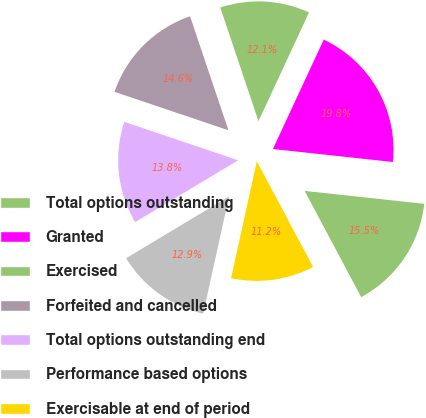Convert chart to OTSL. <chart><loc_0><loc_0><loc_500><loc_500><pie_chart><fcel>Total options outstanding<fcel>Granted<fcel>Exercised<fcel>Forfeited and cancelled<fcel>Total options outstanding end<fcel>Performance based options<fcel>Exercisable at end of period<nl><fcel>15.5%<fcel>19.79%<fcel>12.09%<fcel>14.65%<fcel>13.79%<fcel>12.94%<fcel>11.24%<nl></chart> 